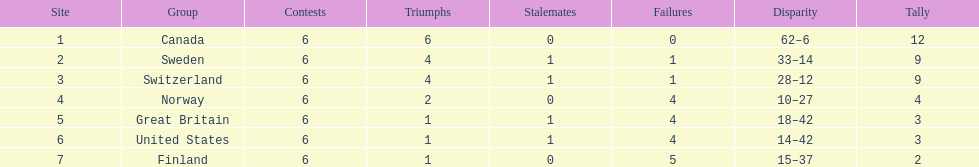How many teams won at least 4 matches? 3. 